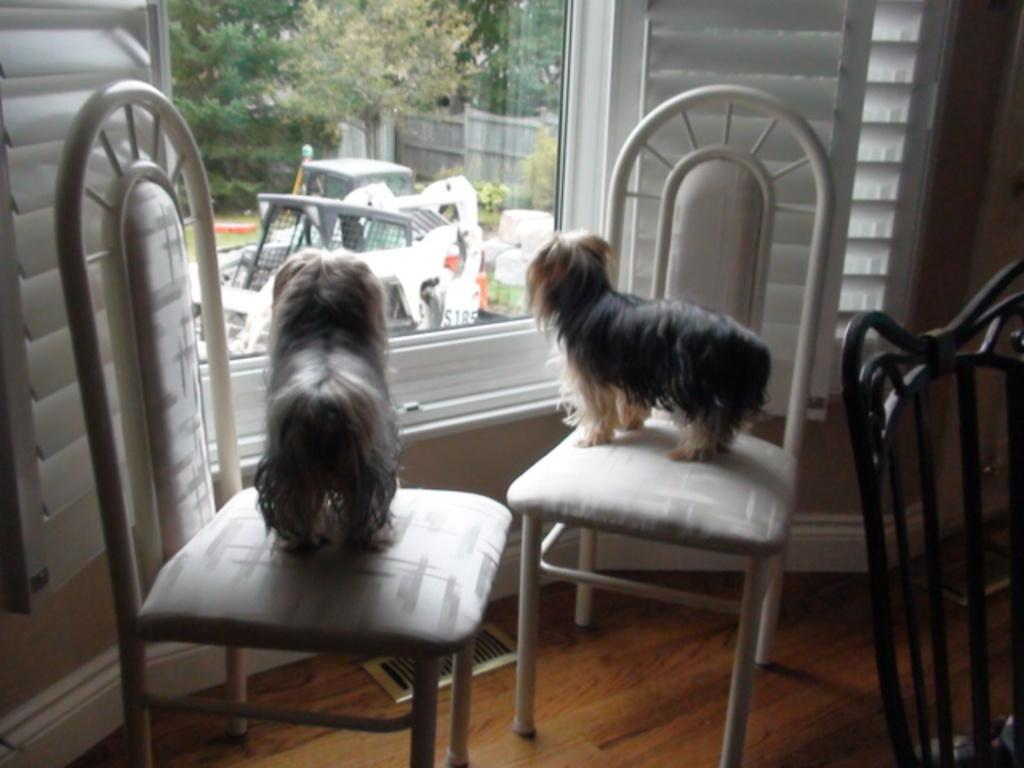How many dogs are in the image? There are two dogs in the image. What are the dogs doing in the image? The dogs are on chairs in the image. What can be seen through the window in the image? Plants are visible from the window in the image. What type of cable is hanging from the wall in the image? There is no cable hanging from the wall in the image; it only features two dogs on chairs and plants visible through a window. 